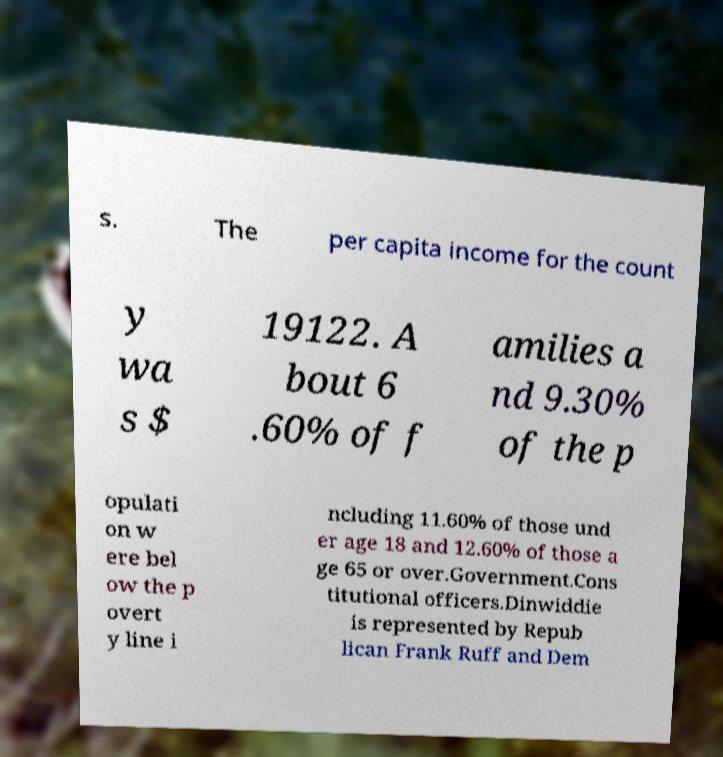Can you accurately transcribe the text from the provided image for me? s. The per capita income for the count y wa s $ 19122. A bout 6 .60% of f amilies a nd 9.30% of the p opulati on w ere bel ow the p overt y line i ncluding 11.60% of those und er age 18 and 12.60% of those a ge 65 or over.Government.Cons titutional officers.Dinwiddie is represented by Repub lican Frank Ruff and Dem 